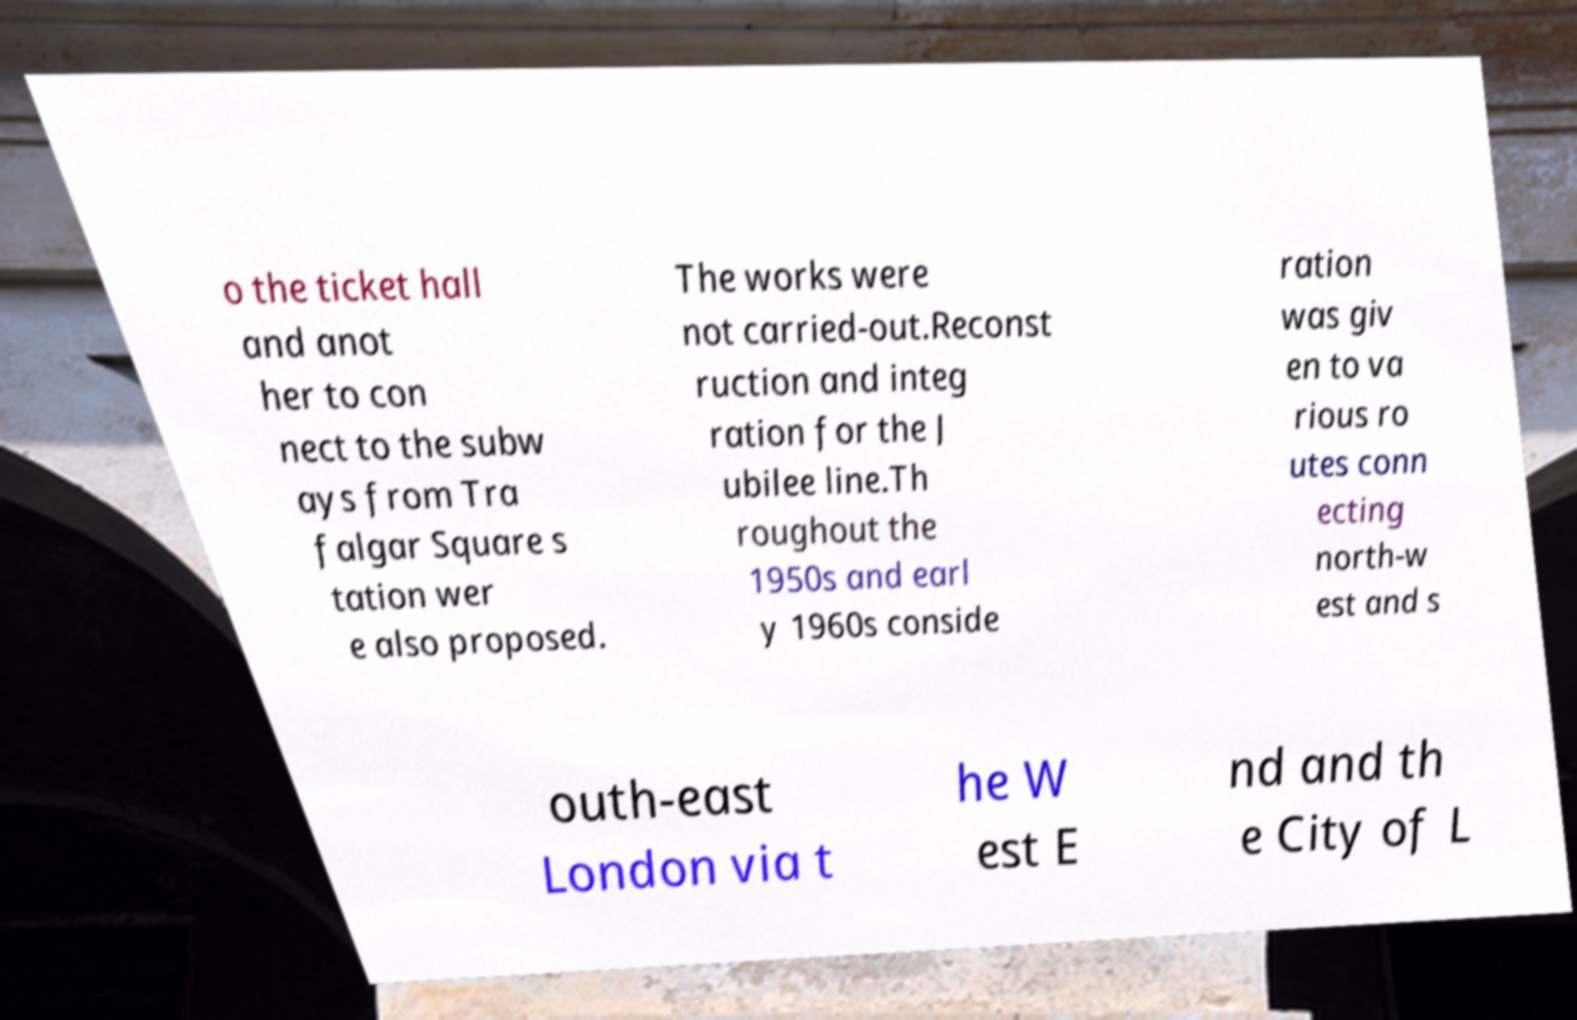There's text embedded in this image that I need extracted. Can you transcribe it verbatim? o the ticket hall and anot her to con nect to the subw ays from Tra falgar Square s tation wer e also proposed. The works were not carried-out.Reconst ruction and integ ration for the J ubilee line.Th roughout the 1950s and earl y 1960s conside ration was giv en to va rious ro utes conn ecting north-w est and s outh-east London via t he W est E nd and th e City of L 